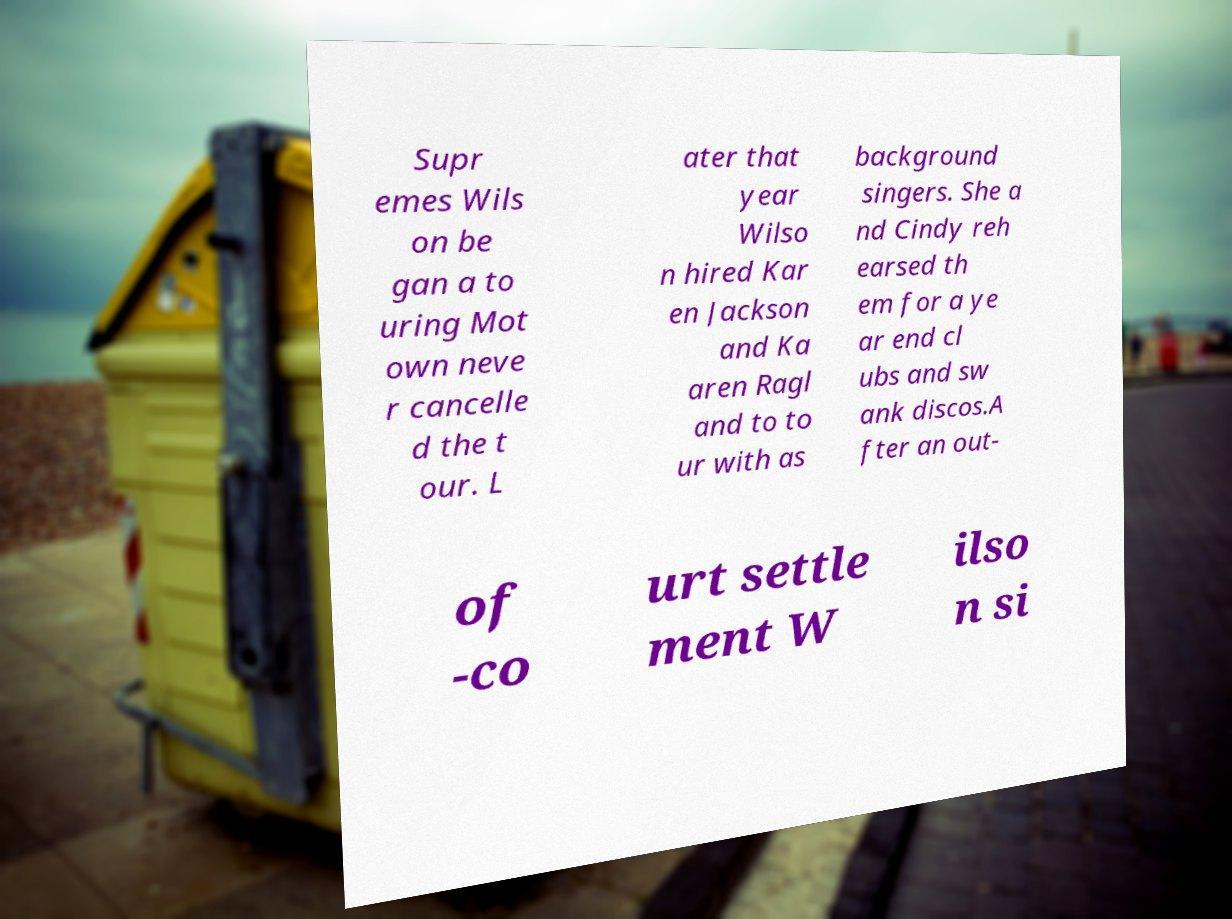Can you accurately transcribe the text from the provided image for me? Supr emes Wils on be gan a to uring Mot own neve r cancelle d the t our. L ater that year Wilso n hired Kar en Jackson and Ka aren Ragl and to to ur with as background singers. She a nd Cindy reh earsed th em for a ye ar end cl ubs and sw ank discos.A fter an out- of -co urt settle ment W ilso n si 